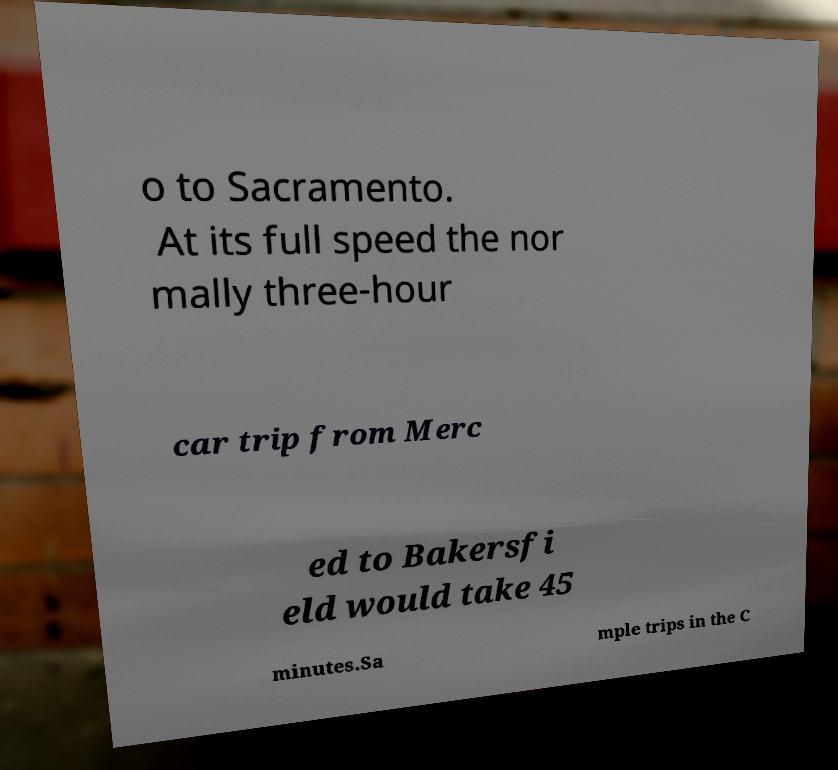Could you extract and type out the text from this image? o to Sacramento. At its full speed the nor mally three-hour car trip from Merc ed to Bakersfi eld would take 45 minutes.Sa mple trips in the C 